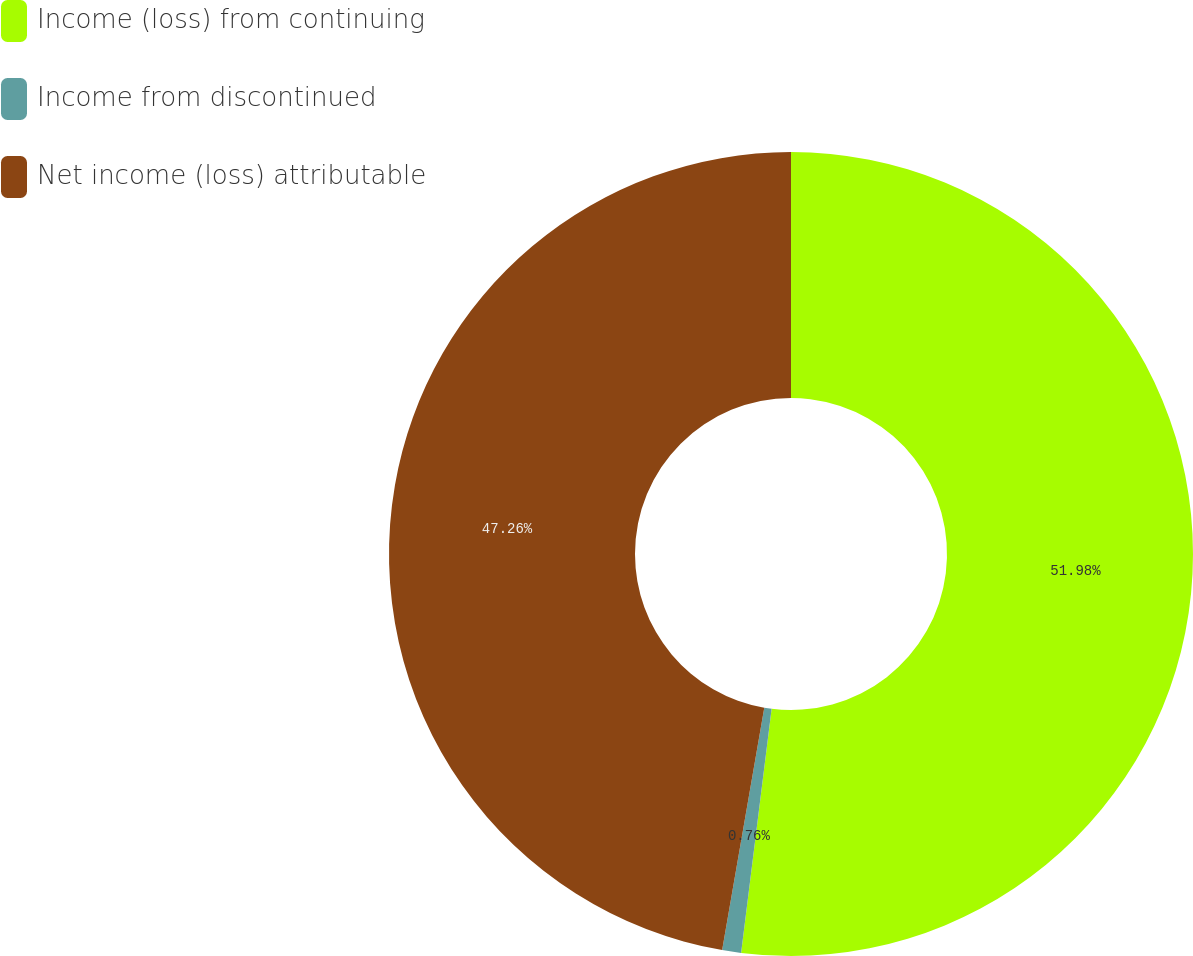<chart> <loc_0><loc_0><loc_500><loc_500><pie_chart><fcel>Income (loss) from continuing<fcel>Income from discontinued<fcel>Net income (loss) attributable<nl><fcel>51.98%<fcel>0.76%<fcel>47.26%<nl></chart> 